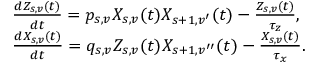<formula> <loc_0><loc_0><loc_500><loc_500>\begin{array} { r l } & { \frac { d Z _ { s , v } ( t ) } { d t } = p _ { s , v } X _ { s , v } ( t ) X _ { s + 1 , v ^ { \prime } } ( t ) - \frac { Z _ { s , v } ( t ) } { \tau _ { z } } , } \\ & { \frac { d X _ { s , v } ( t ) } { d t } = q _ { s , v } Z _ { s , v } ( t ) X _ { s + 1 , v ^ { \prime \prime } } ( t ) - \frac { X _ { s , v } ( t ) } { \tau _ { x } } . } \end{array}</formula> 